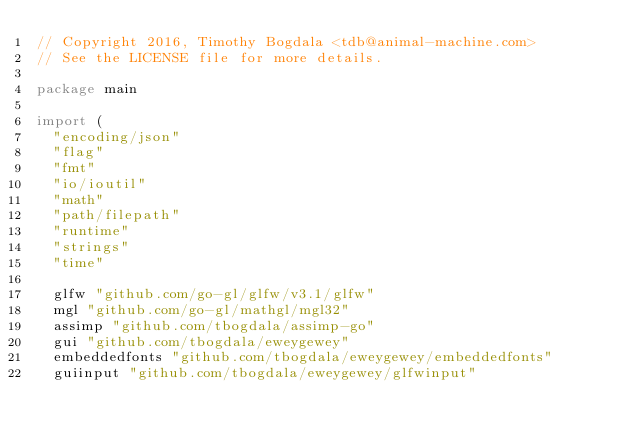Convert code to text. <code><loc_0><loc_0><loc_500><loc_500><_Go_>// Copyright 2016, Timothy Bogdala <tdb@animal-machine.com>
// See the LICENSE file for more details.

package main

import (
	"encoding/json"
	"flag"
	"fmt"
	"io/ioutil"
	"math"
	"path/filepath"
	"runtime"
	"strings"
	"time"

	glfw "github.com/go-gl/glfw/v3.1/glfw"
	mgl "github.com/go-gl/mathgl/mgl32"
	assimp "github.com/tbogdala/assimp-go"
	gui "github.com/tbogdala/eweygewey"
	embeddedfonts "github.com/tbogdala/eweygewey/embeddedfonts"
	guiinput "github.com/tbogdala/eweygewey/glfwinput"</code> 